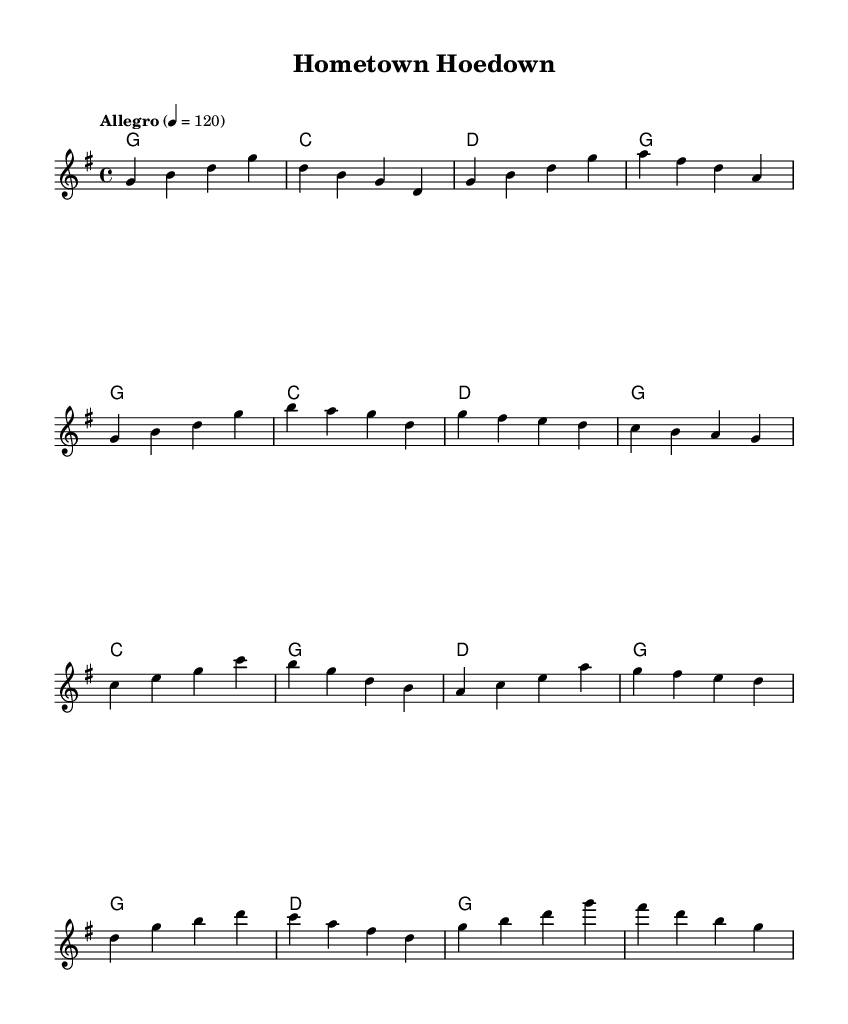What is the key signature of this music? The key signature is G major, indicated by one sharp (F#) in the signature at the beginning of the staff.
Answer: G major What is the time signature of this piece? The time signature is found at the beginning of the sheet music, showing a 4 over 4. This indicates that there are four beats per measure, and the quarter note gets one beat.
Answer: 4/4 What is the tempo marking for this piece? The tempo marking is indicated in the score with the word "Allegro" and a metronome marking of 120. This suggests a fast and lively pace.
Answer: Allegro How many sections are there in the melody? The melody is organized into four distinct sections labeled Intro, A, B, and C, each with different musical phrases that contribute to the overall structure.
Answer: Four sections What is the harmonic progression in the first section? The harmonic progression in the first section follows a simple pattern of G major, C major, D major, and G major, cycling through these chords as indicated in the score.
Answer: G - C - D - G Which instrument typically plays the melody in a bluegrass ensemble? In a bluegrass ensemble, the melody is typically played by instruments such as the banjo, fiddle, or mandolin, which are common for their bright and clear tones.
Answer: Banjo 